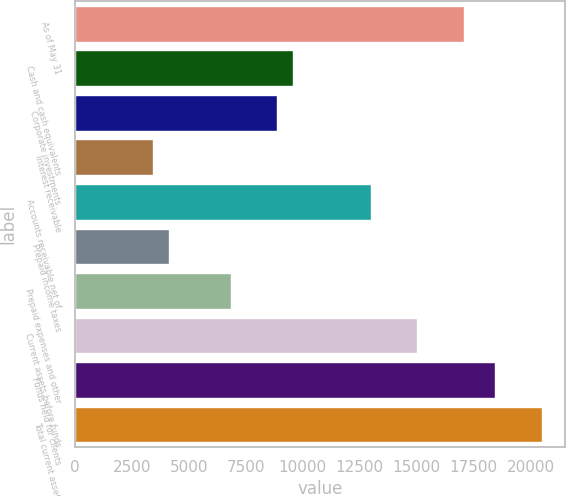Convert chart to OTSL. <chart><loc_0><loc_0><loc_500><loc_500><bar_chart><fcel>As of May 31<fcel>Cash and cash equivalents<fcel>Corporate investments<fcel>Interest receivable<fcel>Accounts receivable net of<fcel>Prepaid income taxes<fcel>Prepaid expenses and other<fcel>Current assets before funds<fcel>Funds held for clients<fcel>Total current assets<nl><fcel>17078.8<fcel>9565.74<fcel>8882.73<fcel>3418.65<fcel>12980.8<fcel>4101.66<fcel>6833.7<fcel>15029.8<fcel>18444.9<fcel>20493.9<nl></chart> 